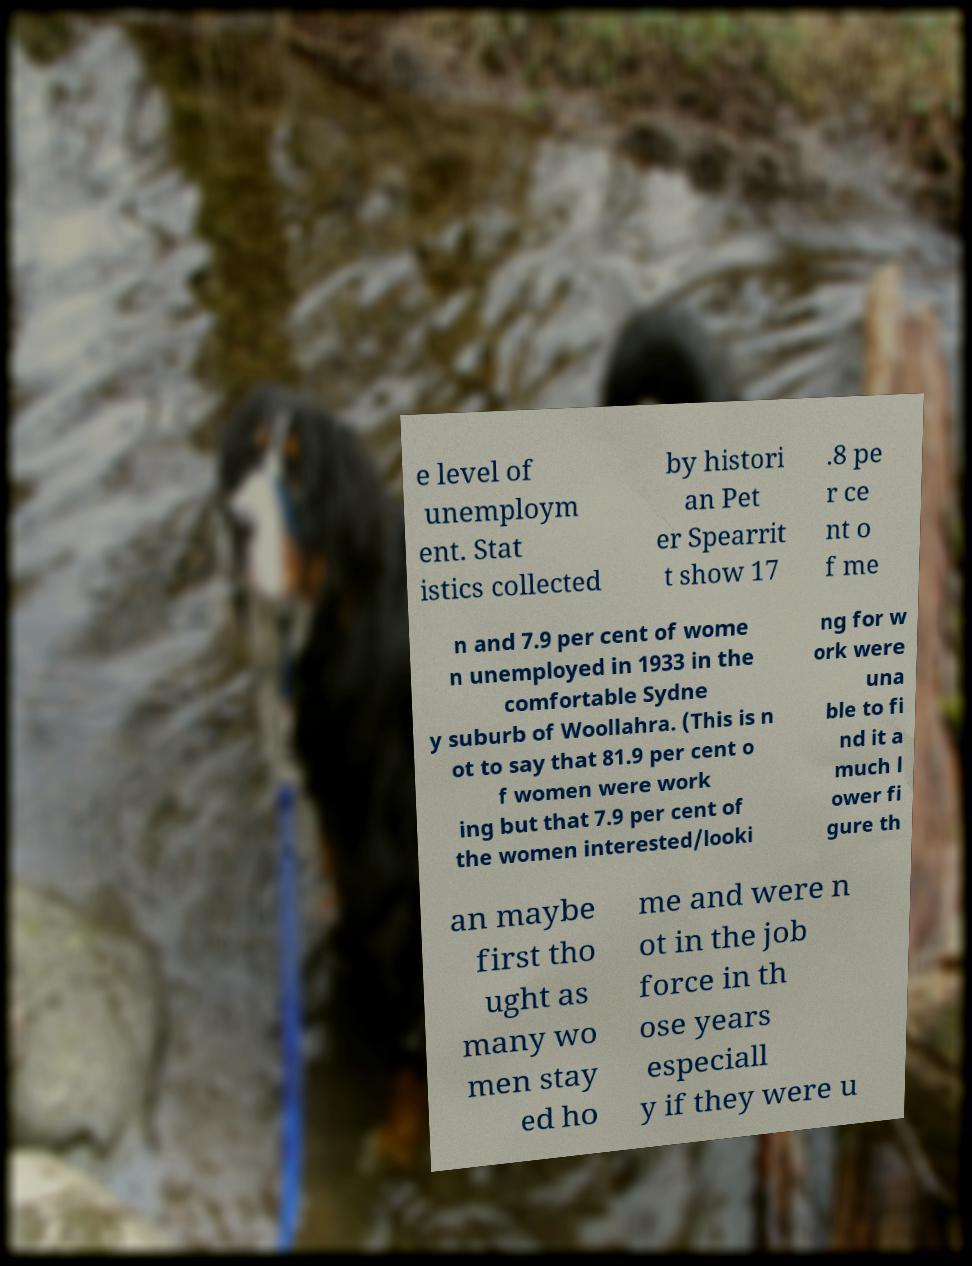For documentation purposes, I need the text within this image transcribed. Could you provide that? e level of unemploym ent. Stat istics collected by histori an Pet er Spearrit t show 17 .8 pe r ce nt o f me n and 7.9 per cent of wome n unemployed in 1933 in the comfortable Sydne y suburb of Woollahra. (This is n ot to say that 81.9 per cent o f women were work ing but that 7.9 per cent of the women interested/looki ng for w ork were una ble to fi nd it a much l ower fi gure th an maybe first tho ught as many wo men stay ed ho me and were n ot in the job force in th ose years especiall y if they were u 